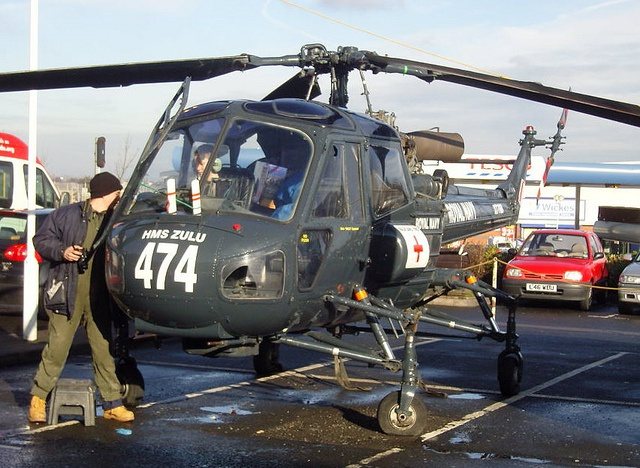Describe the objects in this image and their specific colors. I can see people in lavender, black, gray, and olive tones, car in lavender, gray, black, darkgray, and red tones, truck in lavender, black, ivory, gray, and darkgray tones, car in lavender, black, darkgray, and gray tones, and people in lavender, gray, darkgray, and tan tones in this image. 